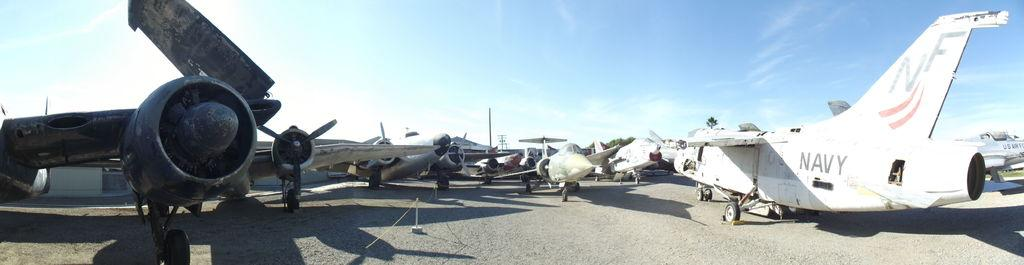<image>
Render a clear and concise summary of the photo. At least one of the planes in the yard is a Navy plane. 